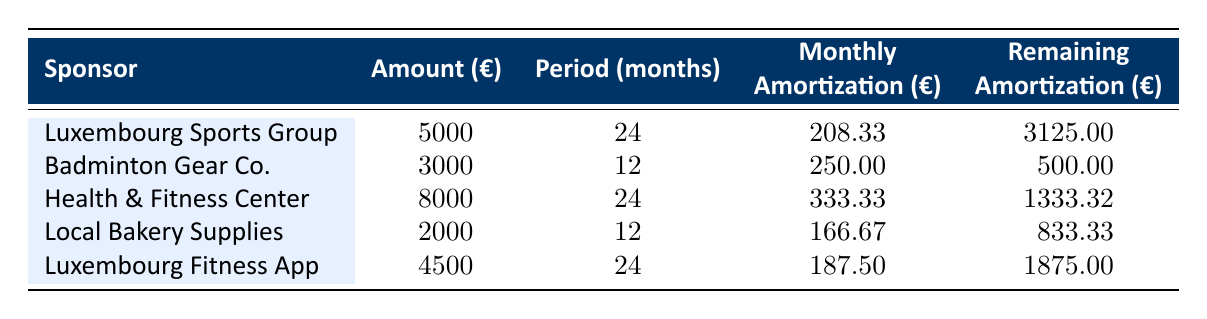What is the total amount sponsored by Luxembourg Sports Group? The table shows the amount sponsored by each sponsor. For Luxembourg Sports Group, the amount is explicitly stated as 5000.
Answer: 5000 How many months is the amortization period for Health & Fitness Center? The amortization period for each sponsor is listed in the table. Health & Fitness Center has an amortization period of 24 months.
Answer: 24 months Which sponsor has the highest monthly amortization? To find the highest monthly amortization, we compare the monthly amortization values: 208.33 (Luxembourg Sports Group), 250.00 (Badminton Gear Co.), 333.33 (Health & Fitness Center), 166.67 (Local Bakery Supplies), and 187.50 (Luxembourg Fitness App). Health & Fitness Center has the highest value of 333.33.
Answer: Health & Fitness Center Is the remaining amortization for Badminton Gear Co. greater than that of Local Bakery Supplies? The remaining amortization for Badminton Gear Co. is 500.00, while for Local Bakery Supplies it is 833.33. Since 500.00 is less than 833.33, the statement is false.
Answer: No What is the total remaining amortization of all sponsors combined? To find the total remaining amortization, we sum the remaining amortization values: 3125.00 (Luxembourg Sports Group) + 500.00 (Badminton Gear Co.) + 1333.32 (Health & Fitness Center) + 833.33 (Local Bakery Supplies) + 1875.00 (Luxembourg Fitness App) = 6876.65.
Answer: 6876.65 How much more is the remaining amortization for Luxembourg Fitness App compared to Badminton Gear Co.? The remaining amortization for Luxembourg Fitness App is 1875.00, and for Badminton Gear Co. it is 500.00. To find the difference, we subtract: 1875.00 - 500.00 = 1375.00.
Answer: 1375.00 Which sponsors have a monthly amortization of less than 200? We can look at the monthly amortization values: 208.33 (Luxembourg Sports Group), 250.00 (Badminton Gear Co.), 333.33 (Health & Fitness Center), 166.67 (Local Bakery Supplies), and 187.50 (Luxembourg Fitness App). The sponsors with monthly amortization less than 200 are Local Bakery Supplies (166.67) and Luxembourg Fitness App (187.50).
Answer: Local Bakery Supplies and Luxembourg Fitness App Is the total amount sponsored by health-related companies (Health & Fitness Center and Luxembourg Fitness App) greater than the total amount sponsored by the other companies? The total amount for health-related sponsors is 8000 (Health & Fitness Center) + 4500 (Luxembourg Fitness App) = 12500. The total amount for other sponsors (Luxembourg Sports Group, Badminton Gear Co., and Local Bakery Supplies) is 5000 + 3000 + 2000 = 10000. Since 12500 is greater than 10000, the statement is true.
Answer: Yes 